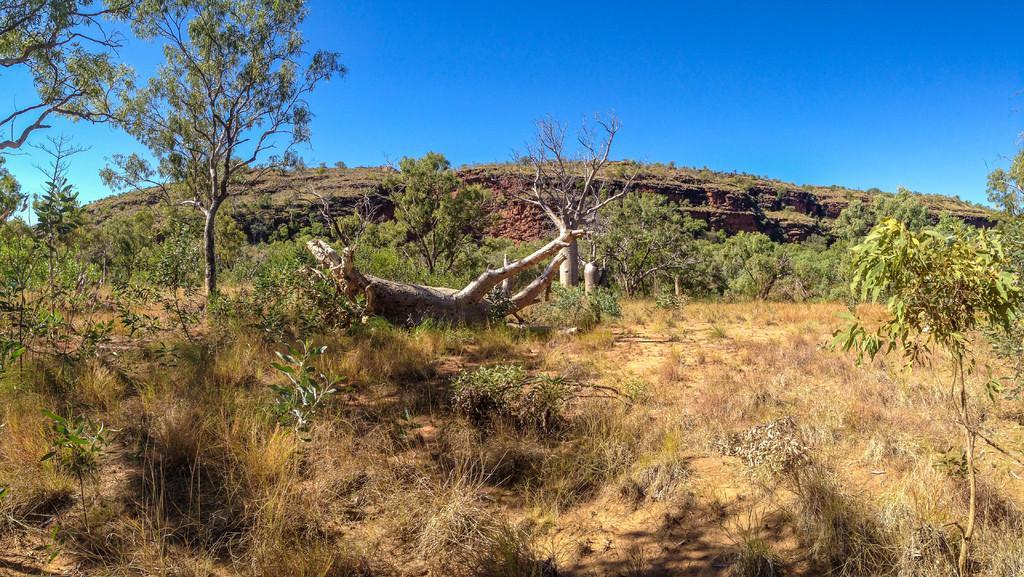Can you describe this image briefly? Here in this picture we can see the ground is fully covered with grass and we can also see plants and trees present and we can also see logs present on the ground and we can see the sky is clear. 